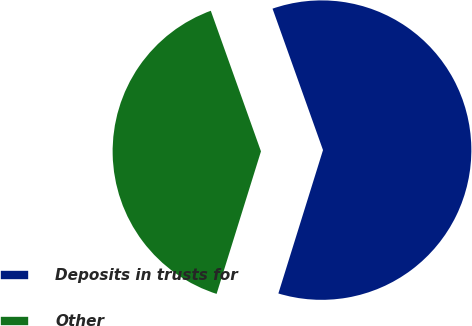Convert chart to OTSL. <chart><loc_0><loc_0><loc_500><loc_500><pie_chart><fcel>Deposits in trusts for<fcel>Other<nl><fcel>60.26%<fcel>39.74%<nl></chart> 